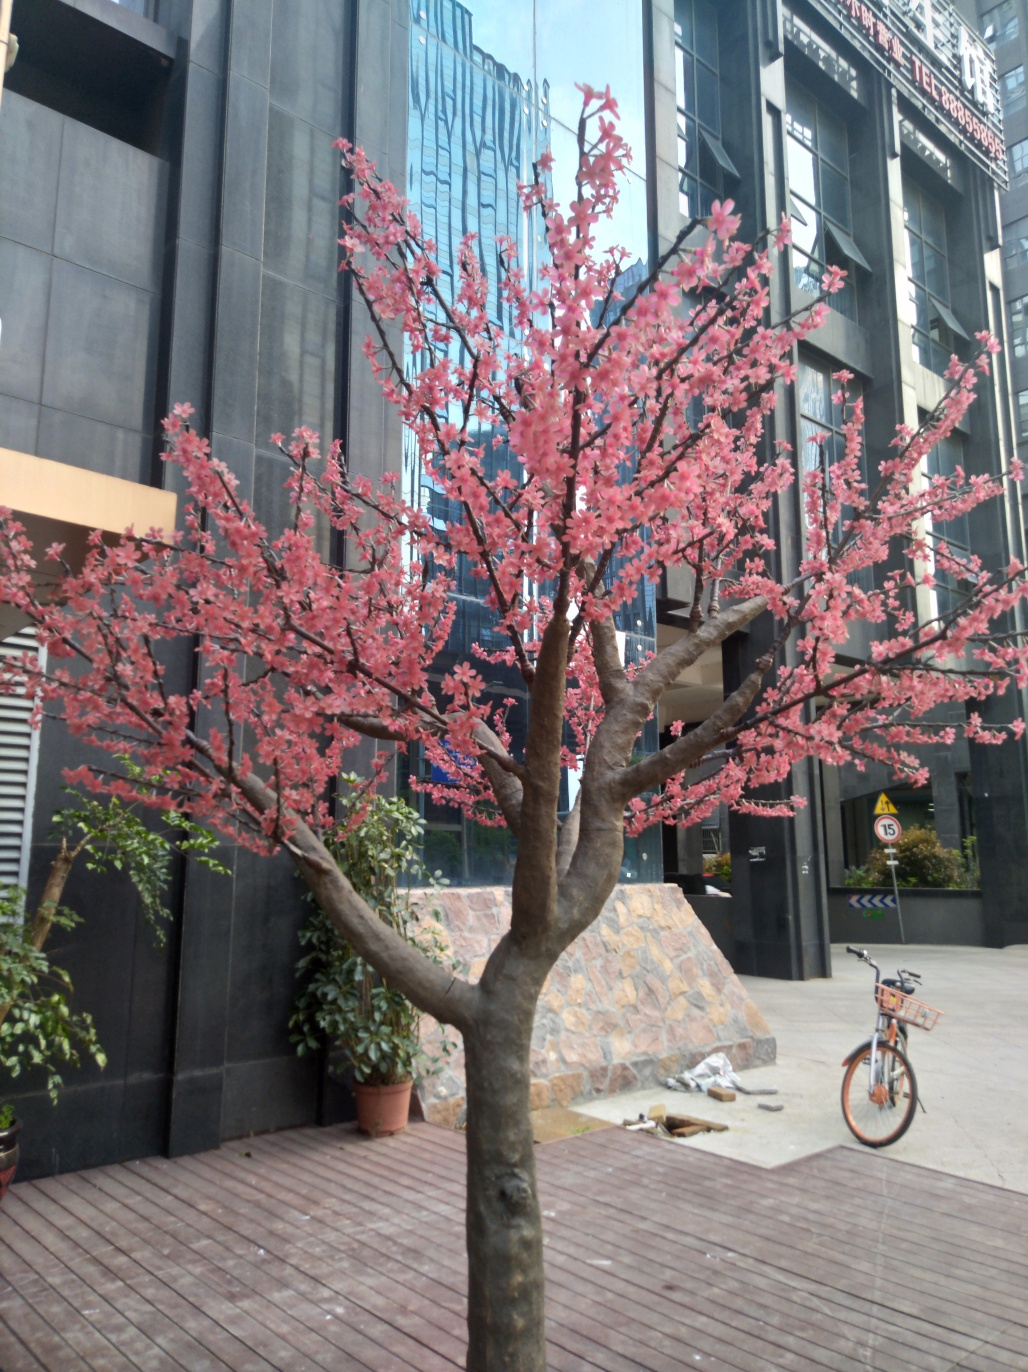What is the color of the flowers? The flowers on the tree are a soft shade of pink, reminiscent of early cherry blossoms. Each petal is a bright burst of color that stands out against the urban backdrop. 